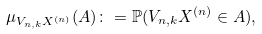<formula> <loc_0><loc_0><loc_500><loc_500>\mu _ { V _ { n , k } X ^ { ( n ) } } ( A ) \colon = \mathbb { P } ( V _ { n , k } X ^ { ( n ) } \in A ) ,</formula> 